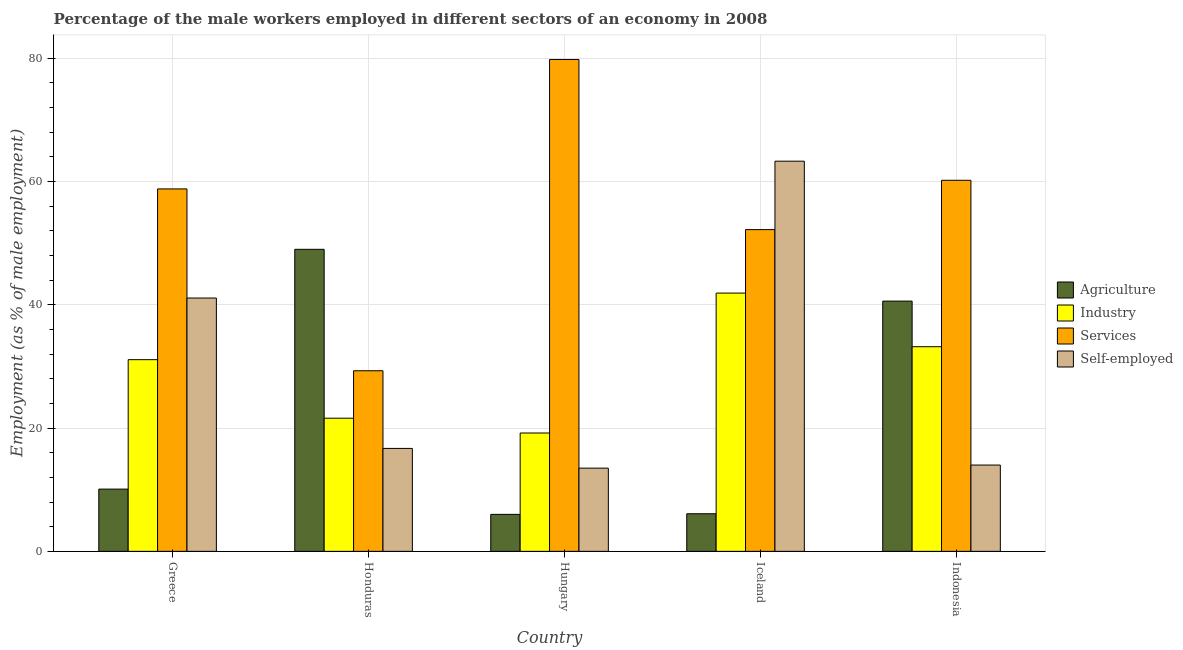How many different coloured bars are there?
Your answer should be very brief. 4. How many groups of bars are there?
Offer a very short reply. 5. Are the number of bars on each tick of the X-axis equal?
Your answer should be very brief. Yes. How many bars are there on the 1st tick from the left?
Your answer should be compact. 4. What is the percentage of self employed male workers in Indonesia?
Provide a short and direct response. 14. Across all countries, what is the maximum percentage of self employed male workers?
Your answer should be compact. 63.3. In which country was the percentage of male workers in agriculture minimum?
Make the answer very short. Hungary. What is the total percentage of self employed male workers in the graph?
Keep it short and to the point. 148.6. What is the difference between the percentage of male workers in agriculture in Greece and that in Hungary?
Keep it short and to the point. 4.1. What is the difference between the percentage of self employed male workers in Indonesia and the percentage of male workers in services in Iceland?
Provide a succinct answer. -38.2. What is the average percentage of male workers in industry per country?
Ensure brevity in your answer.  29.4. What is the ratio of the percentage of male workers in services in Hungary to that in Iceland?
Provide a succinct answer. 1.53. Is the percentage of male workers in industry in Hungary less than that in Iceland?
Your answer should be very brief. Yes. What is the difference between the highest and the second highest percentage of male workers in services?
Ensure brevity in your answer.  19.6. What is the difference between the highest and the lowest percentage of male workers in industry?
Make the answer very short. 22.7. In how many countries, is the percentage of self employed male workers greater than the average percentage of self employed male workers taken over all countries?
Keep it short and to the point. 2. Is the sum of the percentage of male workers in industry in Hungary and Iceland greater than the maximum percentage of male workers in services across all countries?
Make the answer very short. No. Is it the case that in every country, the sum of the percentage of male workers in industry and percentage of male workers in services is greater than the sum of percentage of male workers in agriculture and percentage of self employed male workers?
Make the answer very short. No. What does the 4th bar from the left in Greece represents?
Ensure brevity in your answer.  Self-employed. What does the 2nd bar from the right in Indonesia represents?
Your answer should be very brief. Services. How many countries are there in the graph?
Keep it short and to the point. 5. Are the values on the major ticks of Y-axis written in scientific E-notation?
Your response must be concise. No. Does the graph contain any zero values?
Ensure brevity in your answer.  No. Where does the legend appear in the graph?
Keep it short and to the point. Center right. How many legend labels are there?
Offer a very short reply. 4. What is the title of the graph?
Ensure brevity in your answer.  Percentage of the male workers employed in different sectors of an economy in 2008. What is the label or title of the X-axis?
Offer a terse response. Country. What is the label or title of the Y-axis?
Make the answer very short. Employment (as % of male employment). What is the Employment (as % of male employment) in Agriculture in Greece?
Provide a short and direct response. 10.1. What is the Employment (as % of male employment) of Industry in Greece?
Give a very brief answer. 31.1. What is the Employment (as % of male employment) of Services in Greece?
Offer a terse response. 58.8. What is the Employment (as % of male employment) in Self-employed in Greece?
Offer a terse response. 41.1. What is the Employment (as % of male employment) of Agriculture in Honduras?
Give a very brief answer. 49. What is the Employment (as % of male employment) of Industry in Honduras?
Make the answer very short. 21.6. What is the Employment (as % of male employment) of Services in Honduras?
Your answer should be compact. 29.3. What is the Employment (as % of male employment) in Self-employed in Honduras?
Your answer should be very brief. 16.7. What is the Employment (as % of male employment) in Industry in Hungary?
Keep it short and to the point. 19.2. What is the Employment (as % of male employment) in Services in Hungary?
Keep it short and to the point. 79.8. What is the Employment (as % of male employment) in Self-employed in Hungary?
Your answer should be very brief. 13.5. What is the Employment (as % of male employment) of Agriculture in Iceland?
Keep it short and to the point. 6.1. What is the Employment (as % of male employment) of Industry in Iceland?
Provide a short and direct response. 41.9. What is the Employment (as % of male employment) in Services in Iceland?
Your response must be concise. 52.2. What is the Employment (as % of male employment) in Self-employed in Iceland?
Your answer should be very brief. 63.3. What is the Employment (as % of male employment) of Agriculture in Indonesia?
Give a very brief answer. 40.6. What is the Employment (as % of male employment) in Industry in Indonesia?
Make the answer very short. 33.2. What is the Employment (as % of male employment) of Services in Indonesia?
Provide a succinct answer. 60.2. Across all countries, what is the maximum Employment (as % of male employment) in Industry?
Keep it short and to the point. 41.9. Across all countries, what is the maximum Employment (as % of male employment) of Services?
Your answer should be compact. 79.8. Across all countries, what is the maximum Employment (as % of male employment) in Self-employed?
Keep it short and to the point. 63.3. Across all countries, what is the minimum Employment (as % of male employment) in Agriculture?
Make the answer very short. 6. Across all countries, what is the minimum Employment (as % of male employment) of Industry?
Make the answer very short. 19.2. Across all countries, what is the minimum Employment (as % of male employment) in Services?
Give a very brief answer. 29.3. What is the total Employment (as % of male employment) in Agriculture in the graph?
Give a very brief answer. 111.8. What is the total Employment (as % of male employment) of Industry in the graph?
Provide a succinct answer. 147. What is the total Employment (as % of male employment) of Services in the graph?
Offer a terse response. 280.3. What is the total Employment (as % of male employment) of Self-employed in the graph?
Offer a terse response. 148.6. What is the difference between the Employment (as % of male employment) of Agriculture in Greece and that in Honduras?
Provide a short and direct response. -38.9. What is the difference between the Employment (as % of male employment) in Industry in Greece and that in Honduras?
Offer a terse response. 9.5. What is the difference between the Employment (as % of male employment) in Services in Greece and that in Honduras?
Offer a very short reply. 29.5. What is the difference between the Employment (as % of male employment) in Self-employed in Greece and that in Honduras?
Make the answer very short. 24.4. What is the difference between the Employment (as % of male employment) in Self-employed in Greece and that in Hungary?
Offer a very short reply. 27.6. What is the difference between the Employment (as % of male employment) in Services in Greece and that in Iceland?
Offer a terse response. 6.6. What is the difference between the Employment (as % of male employment) of Self-employed in Greece and that in Iceland?
Offer a terse response. -22.2. What is the difference between the Employment (as % of male employment) of Agriculture in Greece and that in Indonesia?
Provide a short and direct response. -30.5. What is the difference between the Employment (as % of male employment) in Industry in Greece and that in Indonesia?
Your answer should be very brief. -2.1. What is the difference between the Employment (as % of male employment) in Self-employed in Greece and that in Indonesia?
Offer a terse response. 27.1. What is the difference between the Employment (as % of male employment) of Services in Honduras and that in Hungary?
Your answer should be compact. -50.5. What is the difference between the Employment (as % of male employment) in Self-employed in Honduras and that in Hungary?
Ensure brevity in your answer.  3.2. What is the difference between the Employment (as % of male employment) in Agriculture in Honduras and that in Iceland?
Offer a terse response. 42.9. What is the difference between the Employment (as % of male employment) in Industry in Honduras and that in Iceland?
Ensure brevity in your answer.  -20.3. What is the difference between the Employment (as % of male employment) in Services in Honduras and that in Iceland?
Offer a very short reply. -22.9. What is the difference between the Employment (as % of male employment) in Self-employed in Honduras and that in Iceland?
Your response must be concise. -46.6. What is the difference between the Employment (as % of male employment) in Agriculture in Honduras and that in Indonesia?
Your response must be concise. 8.4. What is the difference between the Employment (as % of male employment) of Industry in Honduras and that in Indonesia?
Keep it short and to the point. -11.6. What is the difference between the Employment (as % of male employment) of Services in Honduras and that in Indonesia?
Offer a terse response. -30.9. What is the difference between the Employment (as % of male employment) of Agriculture in Hungary and that in Iceland?
Offer a terse response. -0.1. What is the difference between the Employment (as % of male employment) of Industry in Hungary and that in Iceland?
Make the answer very short. -22.7. What is the difference between the Employment (as % of male employment) of Services in Hungary and that in Iceland?
Provide a short and direct response. 27.6. What is the difference between the Employment (as % of male employment) of Self-employed in Hungary and that in Iceland?
Your response must be concise. -49.8. What is the difference between the Employment (as % of male employment) of Agriculture in Hungary and that in Indonesia?
Keep it short and to the point. -34.6. What is the difference between the Employment (as % of male employment) of Industry in Hungary and that in Indonesia?
Provide a succinct answer. -14. What is the difference between the Employment (as % of male employment) in Services in Hungary and that in Indonesia?
Offer a terse response. 19.6. What is the difference between the Employment (as % of male employment) of Self-employed in Hungary and that in Indonesia?
Provide a short and direct response. -0.5. What is the difference between the Employment (as % of male employment) in Agriculture in Iceland and that in Indonesia?
Keep it short and to the point. -34.5. What is the difference between the Employment (as % of male employment) of Industry in Iceland and that in Indonesia?
Provide a succinct answer. 8.7. What is the difference between the Employment (as % of male employment) in Services in Iceland and that in Indonesia?
Keep it short and to the point. -8. What is the difference between the Employment (as % of male employment) of Self-employed in Iceland and that in Indonesia?
Make the answer very short. 49.3. What is the difference between the Employment (as % of male employment) of Agriculture in Greece and the Employment (as % of male employment) of Services in Honduras?
Make the answer very short. -19.2. What is the difference between the Employment (as % of male employment) of Agriculture in Greece and the Employment (as % of male employment) of Self-employed in Honduras?
Provide a short and direct response. -6.6. What is the difference between the Employment (as % of male employment) in Services in Greece and the Employment (as % of male employment) in Self-employed in Honduras?
Your answer should be very brief. 42.1. What is the difference between the Employment (as % of male employment) in Agriculture in Greece and the Employment (as % of male employment) in Services in Hungary?
Your response must be concise. -69.7. What is the difference between the Employment (as % of male employment) in Agriculture in Greece and the Employment (as % of male employment) in Self-employed in Hungary?
Provide a succinct answer. -3.4. What is the difference between the Employment (as % of male employment) in Industry in Greece and the Employment (as % of male employment) in Services in Hungary?
Your answer should be compact. -48.7. What is the difference between the Employment (as % of male employment) of Services in Greece and the Employment (as % of male employment) of Self-employed in Hungary?
Offer a very short reply. 45.3. What is the difference between the Employment (as % of male employment) in Agriculture in Greece and the Employment (as % of male employment) in Industry in Iceland?
Offer a terse response. -31.8. What is the difference between the Employment (as % of male employment) of Agriculture in Greece and the Employment (as % of male employment) of Services in Iceland?
Make the answer very short. -42.1. What is the difference between the Employment (as % of male employment) in Agriculture in Greece and the Employment (as % of male employment) in Self-employed in Iceland?
Give a very brief answer. -53.2. What is the difference between the Employment (as % of male employment) in Industry in Greece and the Employment (as % of male employment) in Services in Iceland?
Your answer should be very brief. -21.1. What is the difference between the Employment (as % of male employment) of Industry in Greece and the Employment (as % of male employment) of Self-employed in Iceland?
Provide a short and direct response. -32.2. What is the difference between the Employment (as % of male employment) in Services in Greece and the Employment (as % of male employment) in Self-employed in Iceland?
Make the answer very short. -4.5. What is the difference between the Employment (as % of male employment) of Agriculture in Greece and the Employment (as % of male employment) of Industry in Indonesia?
Your answer should be very brief. -23.1. What is the difference between the Employment (as % of male employment) in Agriculture in Greece and the Employment (as % of male employment) in Services in Indonesia?
Provide a short and direct response. -50.1. What is the difference between the Employment (as % of male employment) in Agriculture in Greece and the Employment (as % of male employment) in Self-employed in Indonesia?
Ensure brevity in your answer.  -3.9. What is the difference between the Employment (as % of male employment) of Industry in Greece and the Employment (as % of male employment) of Services in Indonesia?
Ensure brevity in your answer.  -29.1. What is the difference between the Employment (as % of male employment) of Industry in Greece and the Employment (as % of male employment) of Self-employed in Indonesia?
Your response must be concise. 17.1. What is the difference between the Employment (as % of male employment) of Services in Greece and the Employment (as % of male employment) of Self-employed in Indonesia?
Offer a very short reply. 44.8. What is the difference between the Employment (as % of male employment) in Agriculture in Honduras and the Employment (as % of male employment) in Industry in Hungary?
Give a very brief answer. 29.8. What is the difference between the Employment (as % of male employment) of Agriculture in Honduras and the Employment (as % of male employment) of Services in Hungary?
Keep it short and to the point. -30.8. What is the difference between the Employment (as % of male employment) in Agriculture in Honduras and the Employment (as % of male employment) in Self-employed in Hungary?
Provide a short and direct response. 35.5. What is the difference between the Employment (as % of male employment) of Industry in Honduras and the Employment (as % of male employment) of Services in Hungary?
Your answer should be very brief. -58.2. What is the difference between the Employment (as % of male employment) in Industry in Honduras and the Employment (as % of male employment) in Self-employed in Hungary?
Your response must be concise. 8.1. What is the difference between the Employment (as % of male employment) in Agriculture in Honduras and the Employment (as % of male employment) in Industry in Iceland?
Provide a short and direct response. 7.1. What is the difference between the Employment (as % of male employment) in Agriculture in Honduras and the Employment (as % of male employment) in Services in Iceland?
Your answer should be very brief. -3.2. What is the difference between the Employment (as % of male employment) in Agriculture in Honduras and the Employment (as % of male employment) in Self-employed in Iceland?
Give a very brief answer. -14.3. What is the difference between the Employment (as % of male employment) in Industry in Honduras and the Employment (as % of male employment) in Services in Iceland?
Your response must be concise. -30.6. What is the difference between the Employment (as % of male employment) in Industry in Honduras and the Employment (as % of male employment) in Self-employed in Iceland?
Give a very brief answer. -41.7. What is the difference between the Employment (as % of male employment) in Services in Honduras and the Employment (as % of male employment) in Self-employed in Iceland?
Give a very brief answer. -34. What is the difference between the Employment (as % of male employment) in Agriculture in Honduras and the Employment (as % of male employment) in Industry in Indonesia?
Keep it short and to the point. 15.8. What is the difference between the Employment (as % of male employment) in Agriculture in Honduras and the Employment (as % of male employment) in Services in Indonesia?
Keep it short and to the point. -11.2. What is the difference between the Employment (as % of male employment) of Industry in Honduras and the Employment (as % of male employment) of Services in Indonesia?
Keep it short and to the point. -38.6. What is the difference between the Employment (as % of male employment) of Services in Honduras and the Employment (as % of male employment) of Self-employed in Indonesia?
Ensure brevity in your answer.  15.3. What is the difference between the Employment (as % of male employment) in Agriculture in Hungary and the Employment (as % of male employment) in Industry in Iceland?
Your answer should be very brief. -35.9. What is the difference between the Employment (as % of male employment) of Agriculture in Hungary and the Employment (as % of male employment) of Services in Iceland?
Give a very brief answer. -46.2. What is the difference between the Employment (as % of male employment) in Agriculture in Hungary and the Employment (as % of male employment) in Self-employed in Iceland?
Your answer should be compact. -57.3. What is the difference between the Employment (as % of male employment) of Industry in Hungary and the Employment (as % of male employment) of Services in Iceland?
Offer a terse response. -33. What is the difference between the Employment (as % of male employment) in Industry in Hungary and the Employment (as % of male employment) in Self-employed in Iceland?
Keep it short and to the point. -44.1. What is the difference between the Employment (as % of male employment) of Services in Hungary and the Employment (as % of male employment) of Self-employed in Iceland?
Offer a terse response. 16.5. What is the difference between the Employment (as % of male employment) of Agriculture in Hungary and the Employment (as % of male employment) of Industry in Indonesia?
Offer a terse response. -27.2. What is the difference between the Employment (as % of male employment) of Agriculture in Hungary and the Employment (as % of male employment) of Services in Indonesia?
Offer a terse response. -54.2. What is the difference between the Employment (as % of male employment) in Agriculture in Hungary and the Employment (as % of male employment) in Self-employed in Indonesia?
Give a very brief answer. -8. What is the difference between the Employment (as % of male employment) in Industry in Hungary and the Employment (as % of male employment) in Services in Indonesia?
Offer a terse response. -41. What is the difference between the Employment (as % of male employment) in Services in Hungary and the Employment (as % of male employment) in Self-employed in Indonesia?
Ensure brevity in your answer.  65.8. What is the difference between the Employment (as % of male employment) of Agriculture in Iceland and the Employment (as % of male employment) of Industry in Indonesia?
Give a very brief answer. -27.1. What is the difference between the Employment (as % of male employment) in Agriculture in Iceland and the Employment (as % of male employment) in Services in Indonesia?
Provide a short and direct response. -54.1. What is the difference between the Employment (as % of male employment) in Agriculture in Iceland and the Employment (as % of male employment) in Self-employed in Indonesia?
Offer a very short reply. -7.9. What is the difference between the Employment (as % of male employment) of Industry in Iceland and the Employment (as % of male employment) of Services in Indonesia?
Keep it short and to the point. -18.3. What is the difference between the Employment (as % of male employment) of Industry in Iceland and the Employment (as % of male employment) of Self-employed in Indonesia?
Make the answer very short. 27.9. What is the difference between the Employment (as % of male employment) of Services in Iceland and the Employment (as % of male employment) of Self-employed in Indonesia?
Your response must be concise. 38.2. What is the average Employment (as % of male employment) of Agriculture per country?
Give a very brief answer. 22.36. What is the average Employment (as % of male employment) of Industry per country?
Your answer should be very brief. 29.4. What is the average Employment (as % of male employment) of Services per country?
Provide a short and direct response. 56.06. What is the average Employment (as % of male employment) of Self-employed per country?
Offer a very short reply. 29.72. What is the difference between the Employment (as % of male employment) in Agriculture and Employment (as % of male employment) in Services in Greece?
Provide a succinct answer. -48.7. What is the difference between the Employment (as % of male employment) in Agriculture and Employment (as % of male employment) in Self-employed in Greece?
Keep it short and to the point. -31. What is the difference between the Employment (as % of male employment) in Industry and Employment (as % of male employment) in Services in Greece?
Your answer should be compact. -27.7. What is the difference between the Employment (as % of male employment) of Services and Employment (as % of male employment) of Self-employed in Greece?
Your answer should be compact. 17.7. What is the difference between the Employment (as % of male employment) of Agriculture and Employment (as % of male employment) of Industry in Honduras?
Your response must be concise. 27.4. What is the difference between the Employment (as % of male employment) of Agriculture and Employment (as % of male employment) of Self-employed in Honduras?
Give a very brief answer. 32.3. What is the difference between the Employment (as % of male employment) of Services and Employment (as % of male employment) of Self-employed in Honduras?
Your response must be concise. 12.6. What is the difference between the Employment (as % of male employment) in Agriculture and Employment (as % of male employment) in Industry in Hungary?
Provide a succinct answer. -13.2. What is the difference between the Employment (as % of male employment) of Agriculture and Employment (as % of male employment) of Services in Hungary?
Provide a short and direct response. -73.8. What is the difference between the Employment (as % of male employment) of Agriculture and Employment (as % of male employment) of Self-employed in Hungary?
Give a very brief answer. -7.5. What is the difference between the Employment (as % of male employment) in Industry and Employment (as % of male employment) in Services in Hungary?
Make the answer very short. -60.6. What is the difference between the Employment (as % of male employment) of Services and Employment (as % of male employment) of Self-employed in Hungary?
Offer a terse response. 66.3. What is the difference between the Employment (as % of male employment) in Agriculture and Employment (as % of male employment) in Industry in Iceland?
Offer a very short reply. -35.8. What is the difference between the Employment (as % of male employment) in Agriculture and Employment (as % of male employment) in Services in Iceland?
Provide a succinct answer. -46.1. What is the difference between the Employment (as % of male employment) in Agriculture and Employment (as % of male employment) in Self-employed in Iceland?
Offer a terse response. -57.2. What is the difference between the Employment (as % of male employment) of Industry and Employment (as % of male employment) of Self-employed in Iceland?
Provide a succinct answer. -21.4. What is the difference between the Employment (as % of male employment) of Agriculture and Employment (as % of male employment) of Industry in Indonesia?
Your response must be concise. 7.4. What is the difference between the Employment (as % of male employment) in Agriculture and Employment (as % of male employment) in Services in Indonesia?
Provide a short and direct response. -19.6. What is the difference between the Employment (as % of male employment) in Agriculture and Employment (as % of male employment) in Self-employed in Indonesia?
Ensure brevity in your answer.  26.6. What is the difference between the Employment (as % of male employment) in Industry and Employment (as % of male employment) in Self-employed in Indonesia?
Make the answer very short. 19.2. What is the difference between the Employment (as % of male employment) in Services and Employment (as % of male employment) in Self-employed in Indonesia?
Your response must be concise. 46.2. What is the ratio of the Employment (as % of male employment) in Agriculture in Greece to that in Honduras?
Your response must be concise. 0.21. What is the ratio of the Employment (as % of male employment) of Industry in Greece to that in Honduras?
Your answer should be compact. 1.44. What is the ratio of the Employment (as % of male employment) in Services in Greece to that in Honduras?
Ensure brevity in your answer.  2.01. What is the ratio of the Employment (as % of male employment) of Self-employed in Greece to that in Honduras?
Offer a very short reply. 2.46. What is the ratio of the Employment (as % of male employment) of Agriculture in Greece to that in Hungary?
Keep it short and to the point. 1.68. What is the ratio of the Employment (as % of male employment) in Industry in Greece to that in Hungary?
Ensure brevity in your answer.  1.62. What is the ratio of the Employment (as % of male employment) of Services in Greece to that in Hungary?
Keep it short and to the point. 0.74. What is the ratio of the Employment (as % of male employment) in Self-employed in Greece to that in Hungary?
Give a very brief answer. 3.04. What is the ratio of the Employment (as % of male employment) of Agriculture in Greece to that in Iceland?
Offer a very short reply. 1.66. What is the ratio of the Employment (as % of male employment) of Industry in Greece to that in Iceland?
Offer a very short reply. 0.74. What is the ratio of the Employment (as % of male employment) of Services in Greece to that in Iceland?
Make the answer very short. 1.13. What is the ratio of the Employment (as % of male employment) in Self-employed in Greece to that in Iceland?
Provide a short and direct response. 0.65. What is the ratio of the Employment (as % of male employment) of Agriculture in Greece to that in Indonesia?
Ensure brevity in your answer.  0.25. What is the ratio of the Employment (as % of male employment) in Industry in Greece to that in Indonesia?
Provide a short and direct response. 0.94. What is the ratio of the Employment (as % of male employment) in Services in Greece to that in Indonesia?
Ensure brevity in your answer.  0.98. What is the ratio of the Employment (as % of male employment) of Self-employed in Greece to that in Indonesia?
Give a very brief answer. 2.94. What is the ratio of the Employment (as % of male employment) in Agriculture in Honduras to that in Hungary?
Ensure brevity in your answer.  8.17. What is the ratio of the Employment (as % of male employment) in Services in Honduras to that in Hungary?
Your answer should be very brief. 0.37. What is the ratio of the Employment (as % of male employment) in Self-employed in Honduras to that in Hungary?
Give a very brief answer. 1.24. What is the ratio of the Employment (as % of male employment) in Agriculture in Honduras to that in Iceland?
Your response must be concise. 8.03. What is the ratio of the Employment (as % of male employment) in Industry in Honduras to that in Iceland?
Keep it short and to the point. 0.52. What is the ratio of the Employment (as % of male employment) in Services in Honduras to that in Iceland?
Give a very brief answer. 0.56. What is the ratio of the Employment (as % of male employment) of Self-employed in Honduras to that in Iceland?
Make the answer very short. 0.26. What is the ratio of the Employment (as % of male employment) in Agriculture in Honduras to that in Indonesia?
Offer a terse response. 1.21. What is the ratio of the Employment (as % of male employment) of Industry in Honduras to that in Indonesia?
Keep it short and to the point. 0.65. What is the ratio of the Employment (as % of male employment) of Services in Honduras to that in Indonesia?
Offer a very short reply. 0.49. What is the ratio of the Employment (as % of male employment) of Self-employed in Honduras to that in Indonesia?
Offer a terse response. 1.19. What is the ratio of the Employment (as % of male employment) in Agriculture in Hungary to that in Iceland?
Keep it short and to the point. 0.98. What is the ratio of the Employment (as % of male employment) of Industry in Hungary to that in Iceland?
Provide a short and direct response. 0.46. What is the ratio of the Employment (as % of male employment) in Services in Hungary to that in Iceland?
Ensure brevity in your answer.  1.53. What is the ratio of the Employment (as % of male employment) of Self-employed in Hungary to that in Iceland?
Ensure brevity in your answer.  0.21. What is the ratio of the Employment (as % of male employment) of Agriculture in Hungary to that in Indonesia?
Keep it short and to the point. 0.15. What is the ratio of the Employment (as % of male employment) in Industry in Hungary to that in Indonesia?
Provide a short and direct response. 0.58. What is the ratio of the Employment (as % of male employment) in Services in Hungary to that in Indonesia?
Offer a very short reply. 1.33. What is the ratio of the Employment (as % of male employment) in Agriculture in Iceland to that in Indonesia?
Offer a terse response. 0.15. What is the ratio of the Employment (as % of male employment) of Industry in Iceland to that in Indonesia?
Provide a succinct answer. 1.26. What is the ratio of the Employment (as % of male employment) of Services in Iceland to that in Indonesia?
Provide a short and direct response. 0.87. What is the ratio of the Employment (as % of male employment) of Self-employed in Iceland to that in Indonesia?
Offer a terse response. 4.52. What is the difference between the highest and the second highest Employment (as % of male employment) of Agriculture?
Keep it short and to the point. 8.4. What is the difference between the highest and the second highest Employment (as % of male employment) in Industry?
Provide a short and direct response. 8.7. What is the difference between the highest and the second highest Employment (as % of male employment) of Services?
Offer a terse response. 19.6. What is the difference between the highest and the lowest Employment (as % of male employment) in Agriculture?
Your response must be concise. 43. What is the difference between the highest and the lowest Employment (as % of male employment) of Industry?
Your response must be concise. 22.7. What is the difference between the highest and the lowest Employment (as % of male employment) in Services?
Make the answer very short. 50.5. What is the difference between the highest and the lowest Employment (as % of male employment) of Self-employed?
Make the answer very short. 49.8. 